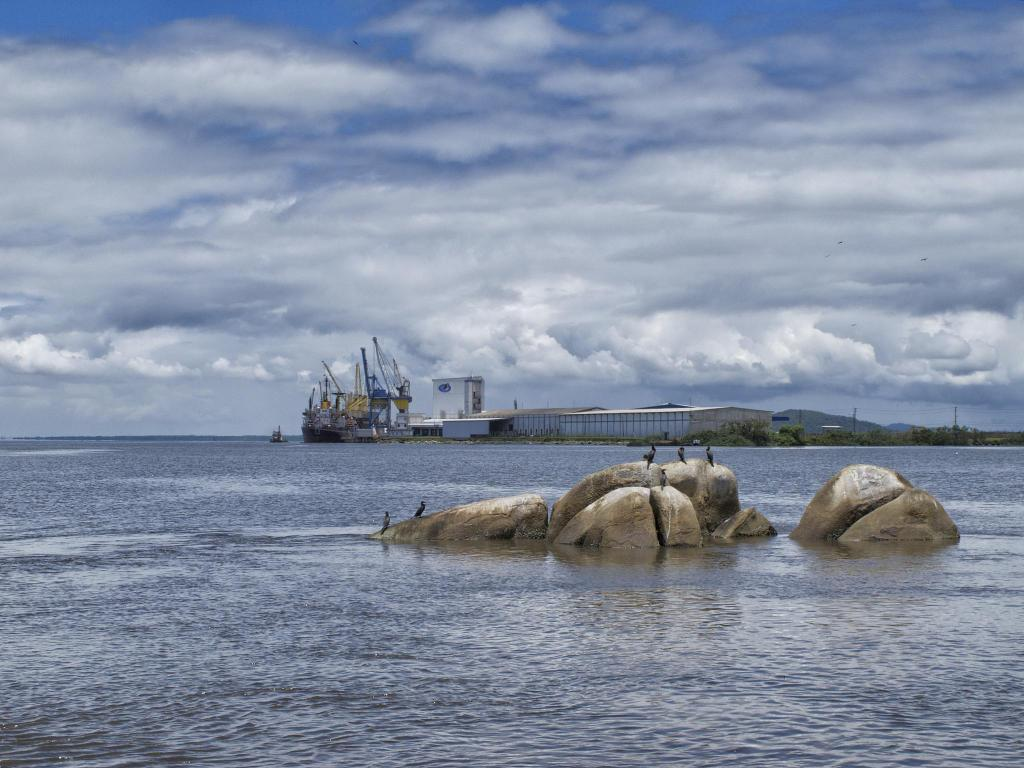What type of natural feature is at the bottom of the image? There is a river at the bottom of the image. What can be found in the center of the image? There are rocks in the center of the image. What type of animals can be seen in the image? Birds are visible in the image. What structures are present in the background of the image? There is a ship and sheds in the background of the image. What type of vegetation is visible in the background of the image? Trees are present in the background of the image. What type of elevation can be seen in the background of the image? There is a hill in the background of the image. What part of the natural environment is visible in the background of the image? The sky is visible in the background of the image. What type of noise can be heard coming from the cornfield in the image? There is no cornfield present in the image, so it's not possible to determine what, if any, noise might be heard. 